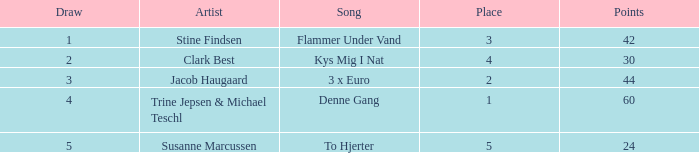What is the average draw amount when the place is more than 5? None. 